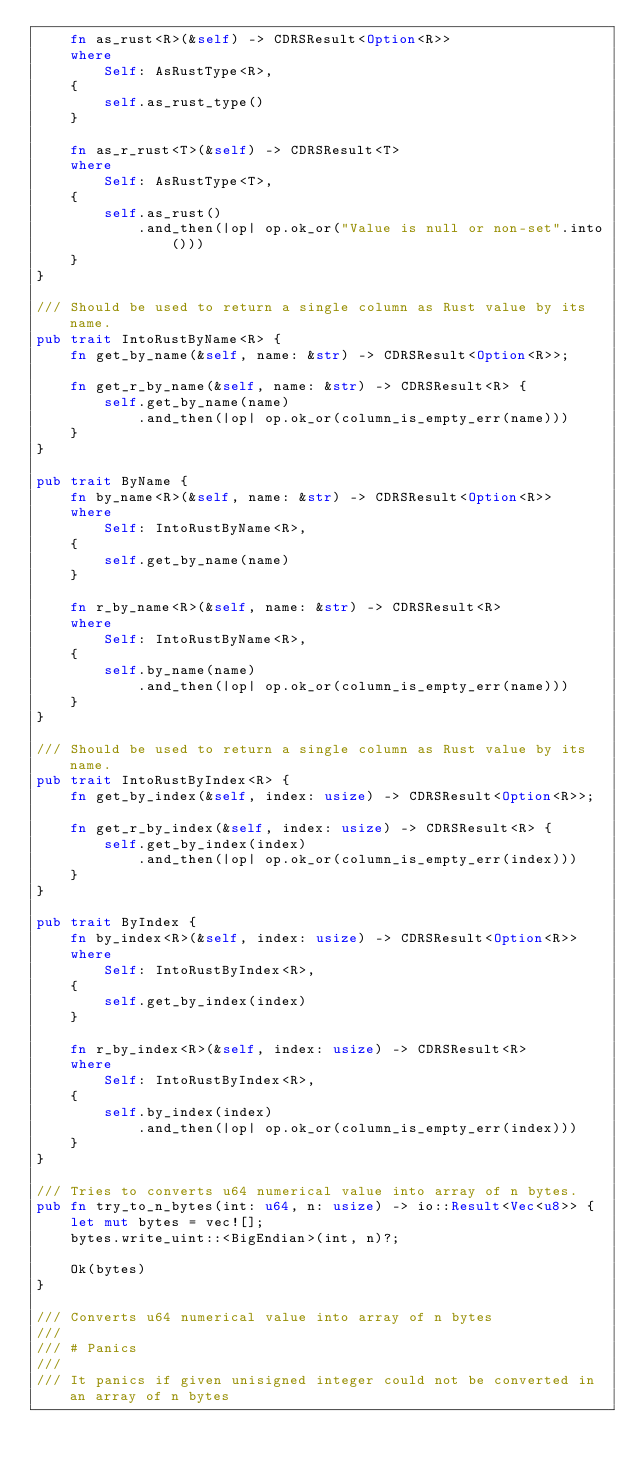Convert code to text. <code><loc_0><loc_0><loc_500><loc_500><_Rust_>    fn as_rust<R>(&self) -> CDRSResult<Option<R>>
    where
        Self: AsRustType<R>,
    {
        self.as_rust_type()
    }

    fn as_r_rust<T>(&self) -> CDRSResult<T>
    where
        Self: AsRustType<T>,
    {
        self.as_rust()
            .and_then(|op| op.ok_or("Value is null or non-set".into()))
    }
}

/// Should be used to return a single column as Rust value by its name.
pub trait IntoRustByName<R> {
    fn get_by_name(&self, name: &str) -> CDRSResult<Option<R>>;

    fn get_r_by_name(&self, name: &str) -> CDRSResult<R> {
        self.get_by_name(name)
            .and_then(|op| op.ok_or(column_is_empty_err(name)))
    }
}

pub trait ByName {
    fn by_name<R>(&self, name: &str) -> CDRSResult<Option<R>>
    where
        Self: IntoRustByName<R>,
    {
        self.get_by_name(name)
    }

    fn r_by_name<R>(&self, name: &str) -> CDRSResult<R>
    where
        Self: IntoRustByName<R>,
    {
        self.by_name(name)
            .and_then(|op| op.ok_or(column_is_empty_err(name)))
    }
}

/// Should be used to return a single column as Rust value by its name.
pub trait IntoRustByIndex<R> {
    fn get_by_index(&self, index: usize) -> CDRSResult<Option<R>>;

    fn get_r_by_index(&self, index: usize) -> CDRSResult<R> {
        self.get_by_index(index)
            .and_then(|op| op.ok_or(column_is_empty_err(index)))
    }
}

pub trait ByIndex {
    fn by_index<R>(&self, index: usize) -> CDRSResult<Option<R>>
    where
        Self: IntoRustByIndex<R>,
    {
        self.get_by_index(index)
    }

    fn r_by_index<R>(&self, index: usize) -> CDRSResult<R>
    where
        Self: IntoRustByIndex<R>,
    {
        self.by_index(index)
            .and_then(|op| op.ok_or(column_is_empty_err(index)))
    }
}

/// Tries to converts u64 numerical value into array of n bytes.
pub fn try_to_n_bytes(int: u64, n: usize) -> io::Result<Vec<u8>> {
    let mut bytes = vec![];
    bytes.write_uint::<BigEndian>(int, n)?;

    Ok(bytes)
}

/// Converts u64 numerical value into array of n bytes
///
/// # Panics
///
/// It panics if given unisigned integer could not be converted in an array of n bytes</code> 